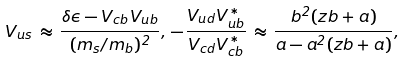<formula> <loc_0><loc_0><loc_500><loc_500>V _ { u s } \, \approx \, \frac { \delta \epsilon - V _ { c b } V _ { u b } } { ( m _ { s } / m _ { b } ) ^ { 2 } } , \, - \frac { V _ { u d } V _ { u b } ^ { * } } { V _ { c d } V _ { c b } ^ { * } } \, \approx \, \frac { b ^ { 2 } ( z b + a ) } { a - a ^ { 2 } ( z b + a ) } , \,</formula> 